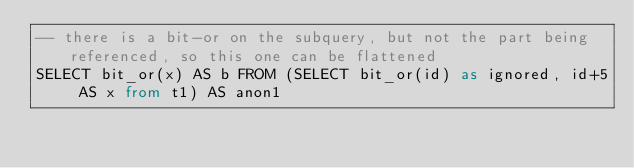Convert code to text. <code><loc_0><loc_0><loc_500><loc_500><_SQL_>-- there is a bit-or on the subquery, but not the part being referenced, so this one can be flattened
SELECT bit_or(x) AS b FROM (SELECT bit_or(id) as ignored, id+5 AS x from t1) AS anon1</code> 